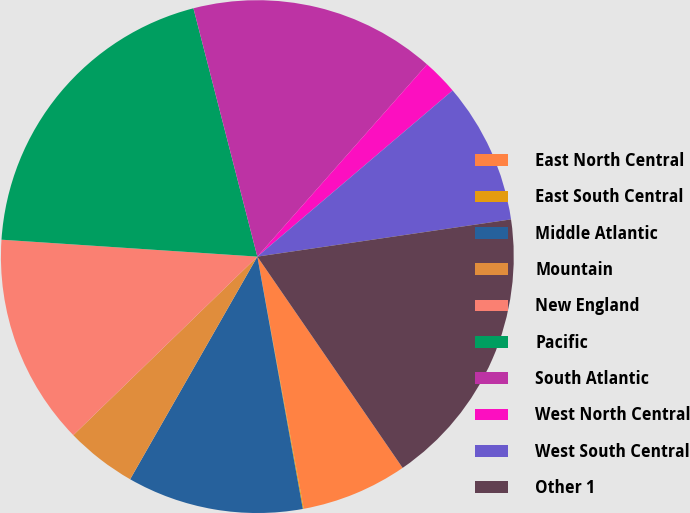Convert chart. <chart><loc_0><loc_0><loc_500><loc_500><pie_chart><fcel>East North Central<fcel>East South Central<fcel>Middle Atlantic<fcel>Mountain<fcel>New England<fcel>Pacific<fcel>South Atlantic<fcel>West North Central<fcel>West South Central<fcel>Other 1<nl><fcel>6.69%<fcel>0.06%<fcel>11.1%<fcel>4.48%<fcel>13.31%<fcel>19.94%<fcel>15.52%<fcel>2.27%<fcel>8.9%<fcel>17.73%<nl></chart> 